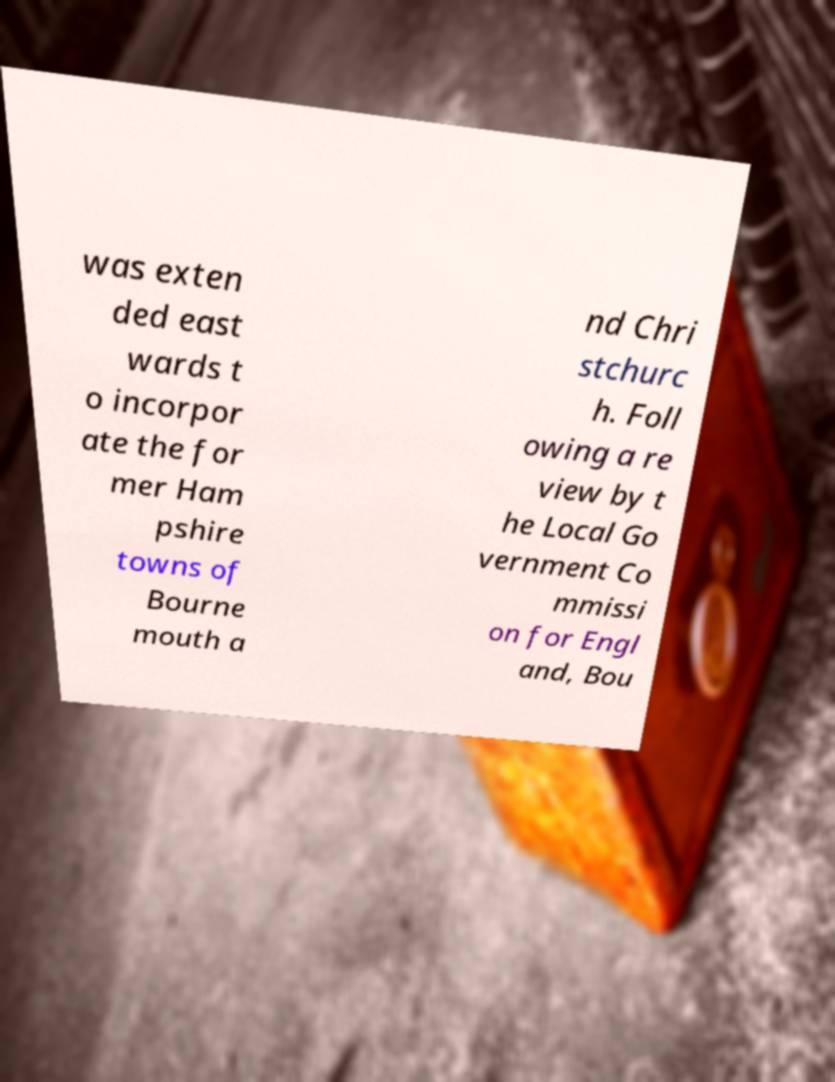Can you read and provide the text displayed in the image?This photo seems to have some interesting text. Can you extract and type it out for me? was exten ded east wards t o incorpor ate the for mer Ham pshire towns of Bourne mouth a nd Chri stchurc h. Foll owing a re view by t he Local Go vernment Co mmissi on for Engl and, Bou 